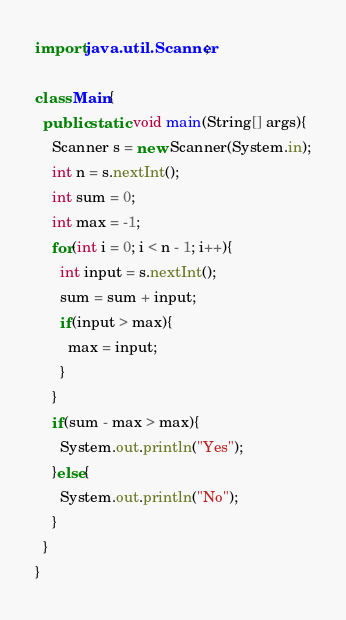<code> <loc_0><loc_0><loc_500><loc_500><_Java_>import java.util.Scanner;

class Main{
  public static void main(String[] args){
    Scanner s = new Scanner(System.in);
    int n = s.nextInt();
    int sum = 0;
    int max = -1;
    for(int i = 0; i < n - 1; i++){
      int input = s.nextInt();
      sum = sum + input;
      if(input > max){
        max = input;
      }
    }
    if(sum - max > max){
      System.out.println("Yes");
    }else{
      System.out.println("No");
    }
  }
}</code> 